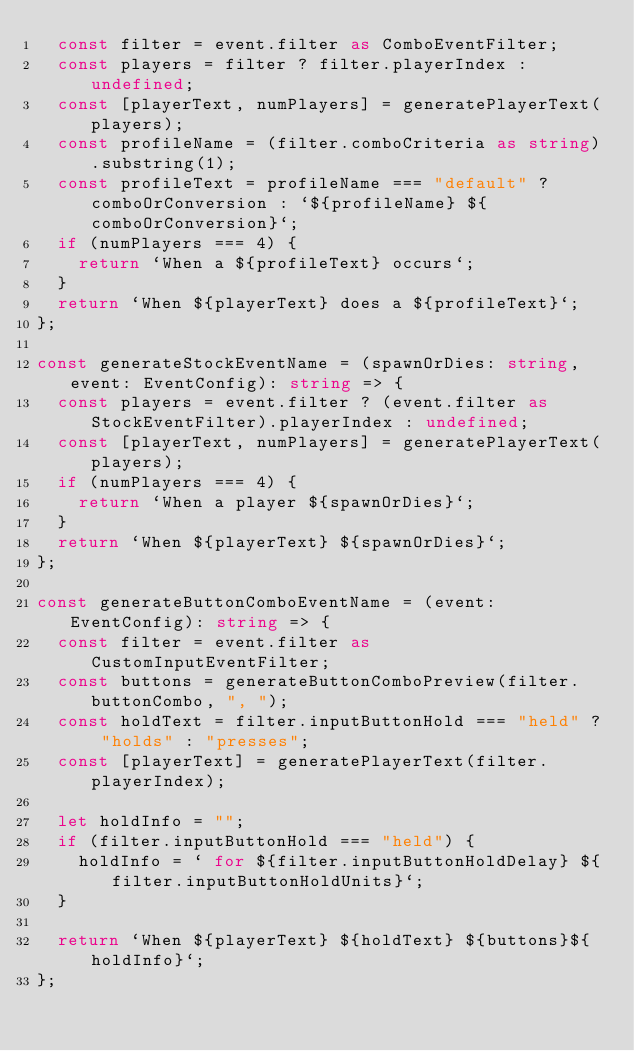Convert code to text. <code><loc_0><loc_0><loc_500><loc_500><_TypeScript_>  const filter = event.filter as ComboEventFilter;
  const players = filter ? filter.playerIndex : undefined;
  const [playerText, numPlayers] = generatePlayerText(players);
  const profileName = (filter.comboCriteria as string).substring(1);
  const profileText = profileName === "default" ? comboOrConversion : `${profileName} ${comboOrConversion}`;
  if (numPlayers === 4) {
    return `When a ${profileText} occurs`;
  }
  return `When ${playerText} does a ${profileText}`;
};

const generateStockEventName = (spawnOrDies: string, event: EventConfig): string => {
  const players = event.filter ? (event.filter as StockEventFilter).playerIndex : undefined;
  const [playerText, numPlayers] = generatePlayerText(players);
  if (numPlayers === 4) {
    return `When a player ${spawnOrDies}`;
  }
  return `When ${playerText} ${spawnOrDies}`;
};

const generateButtonComboEventName = (event: EventConfig): string => {
  const filter = event.filter as CustomInputEventFilter;
  const buttons = generateButtonComboPreview(filter.buttonCombo, ", ");
  const holdText = filter.inputButtonHold === "held" ? "holds" : "presses";
  const [playerText] = generatePlayerText(filter.playerIndex);

  let holdInfo = "";
  if (filter.inputButtonHold === "held") {
    holdInfo = ` for ${filter.inputButtonHoldDelay} ${filter.inputButtonHoldUnits}`;
  }

  return `When ${playerText} ${holdText} ${buttons}${holdInfo}`;
};
</code> 